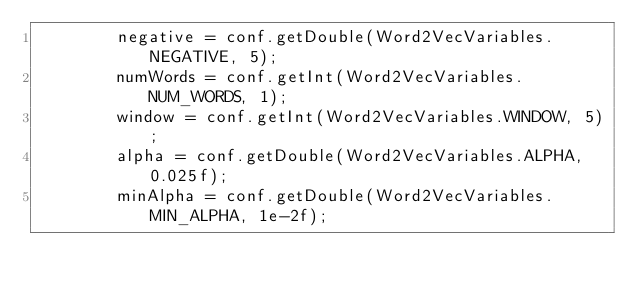Convert code to text. <code><loc_0><loc_0><loc_500><loc_500><_Java_>        negative = conf.getDouble(Word2VecVariables.NEGATIVE, 5);
        numWords = conf.getInt(Word2VecVariables.NUM_WORDS, 1);
        window = conf.getInt(Word2VecVariables.WINDOW, 5);
        alpha = conf.getDouble(Word2VecVariables.ALPHA, 0.025f);
        minAlpha = conf.getDouble(Word2VecVariables.MIN_ALPHA, 1e-2f);</code> 